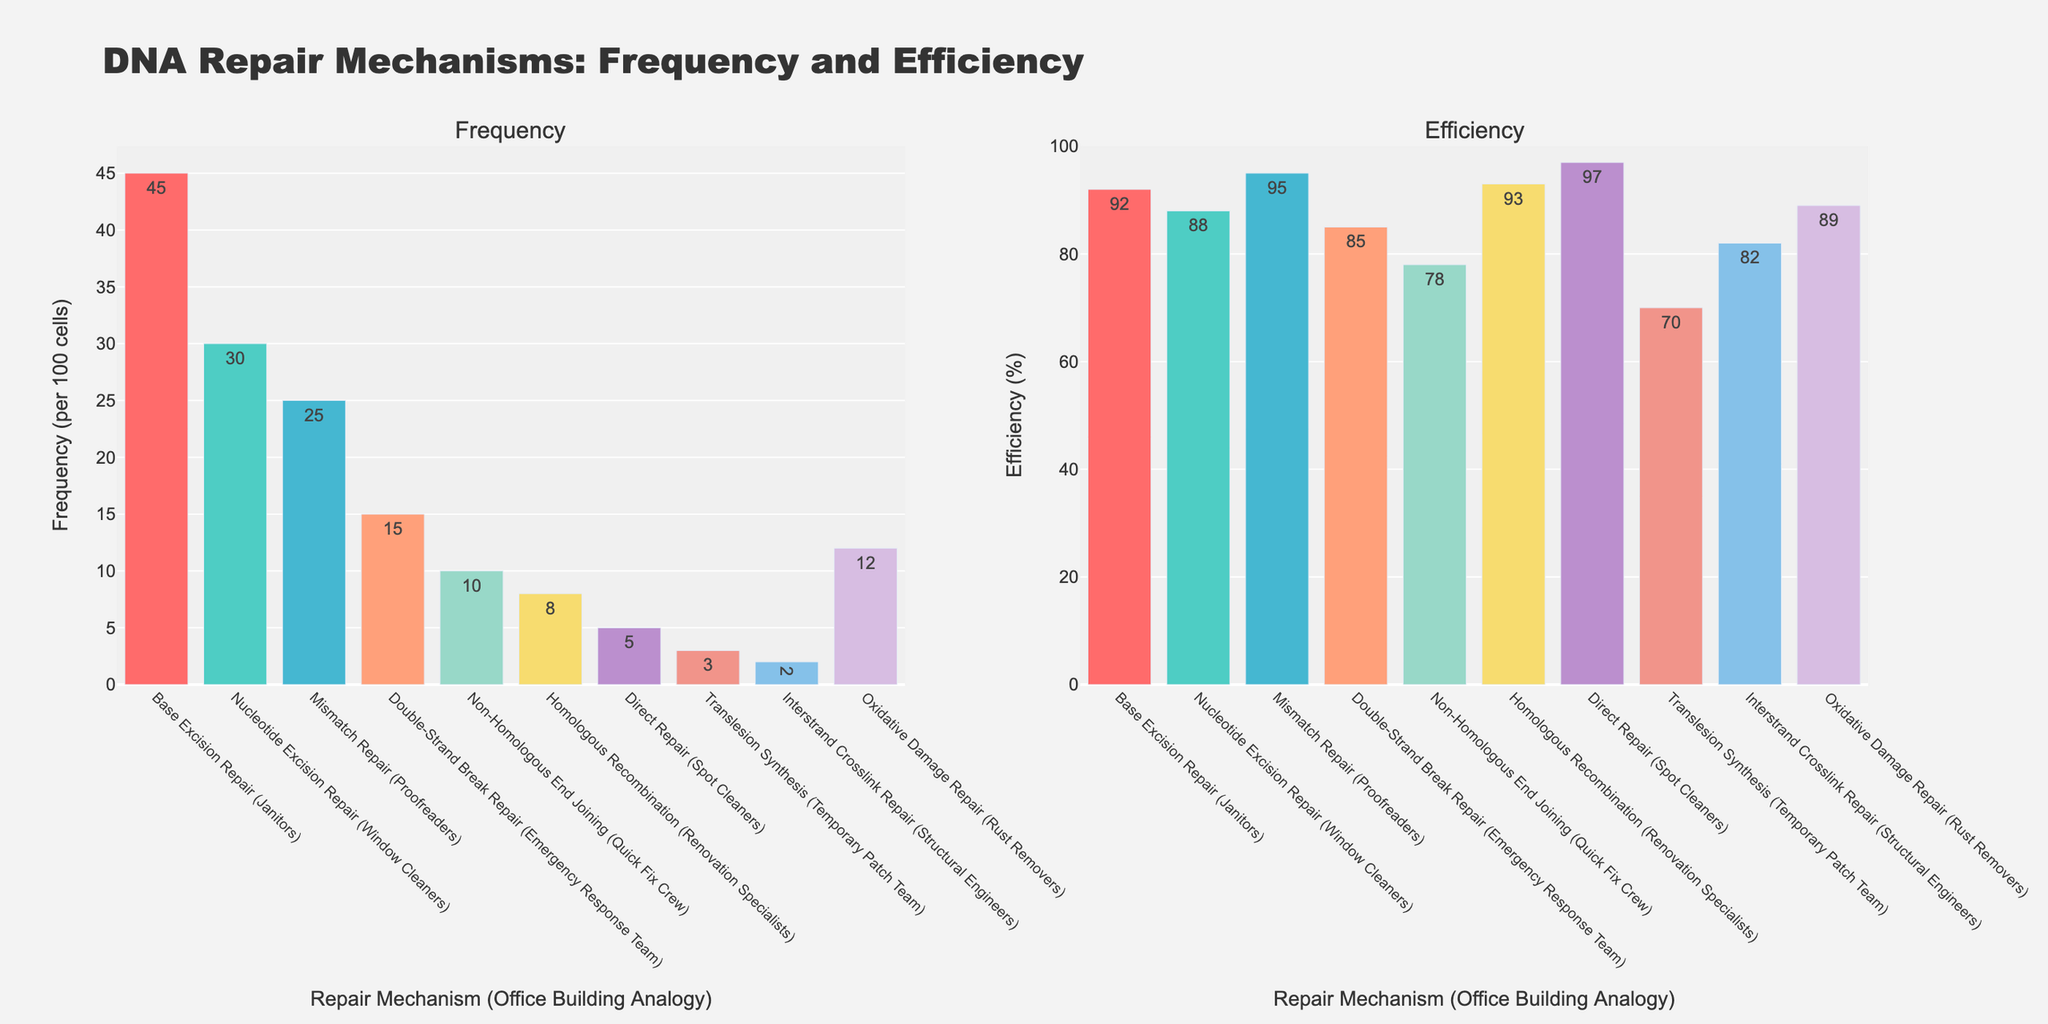What is the most frequent DNA repair mechanism in cells according to the chart? The bar chart shows that "Base Excision Repair (Janitors)" has the highest bar in the Frequency subplot. The label indicates 45 per 100 cells.
Answer: Base Excision Repair (Janitors) How does the efficiency of the "Mismatch Repair (Proofreaders)" compare to the efficiency of the "Non-Homologous End Joining (Quick Fix Crew)"? The efficiency percentage of the "Mismatch Repair (Proofreaders)" is 95% whereas the "Non-Homologous End Joining (Quick Fix Crew)" is 78%. Therefore, "Mismatch Repair (Proofreaders)" is more efficient.
Answer: Mismatch Repair (Proofreaders) is more efficient Which DNA repair mechanism has the lowest frequency and what is its efficiency? The "Interstrand Crosslink Repair (Structural Engineers)" has the lowest frequency, with 2 per 100 cells. Its efficiency is labeled as 82%.
Answer: Interstrand Crosslink Repair (Structural Engineers), 82% If you sum the frequencies of "Double-Strand Break Repair (Emergency Response Team)" and "Oxidative Damage Repair (Rust Removers)", what is the total? The frequency of "Double-Strand Break Repair (Emergency Response Team)" is 15 per 100 cells and the frequency of "Oxidative Damage Repair (Rust Removers)" is 12 per 100 cells. Adding them gives 15 + 12 = 27 per 100 cells.
Answer: 27 per 100 cells What is the combined efficiency of the top two most efficient repair mechanisms? The two most efficient repair mechanisms are "Direct Repair (Spot Cleaners)" with 97%, and "Mismatch Repair (Proofreaders)" with 95%. Combined efficiency is 97 + 95 = 192%.
Answer: 192% Which repair mechanism is represented by a cyan-colored bar and what are its frequency and efficiency? The bar colored cyan represents "Nucleotide Excision Repair (Window Cleaners)". According to the subplots, its frequency is 30 per 100 cells and efficiency is 88%.
Answer: Nucleotide Excision Repair (Window Cleaners), 30 per 100 cells, 88% What is the difference in efficiency between "Homologous Recombination (Renovation Specialists)" and "Translesion Synthesis (Temporary Patch Team)"? The efficiency of "Homologous Recombination (Renovation Specialists)" is 93%, and "Translesion Synthesis (Temporary Patch Team)" is 70%. The difference is 93 - 70 = 23%.
Answer: 23% How much more frequent is the "Oxidative Damage Repair (Rust Removers)" compared to "Direct Repair (Spot Cleaners)"? "Oxidative Damage Repair (Rust Removers)" has a frequency of 12 per 100 cells and "Direct Repair (Spot Cleaners)" has a frequency of 5 per 100 cells. The difference is 12 - 5 = 7 per 100 cells.
Answer: 7 per 100 cells 